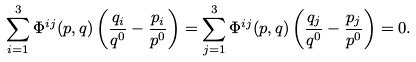<formula> <loc_0><loc_0><loc_500><loc_500>\sum _ { i = 1 } ^ { 3 } \Phi ^ { i j } ( p , q ) \left ( \frac { q _ { i } } { q ^ { 0 } } - \frac { p _ { i } } { p ^ { 0 } } \right ) = \sum _ { j = 1 } ^ { 3 } \Phi ^ { i j } ( p , q ) \left ( \frac { q _ { j } } { q ^ { 0 } } - \frac { p _ { j } } { p ^ { 0 } } \right ) = 0 .</formula> 